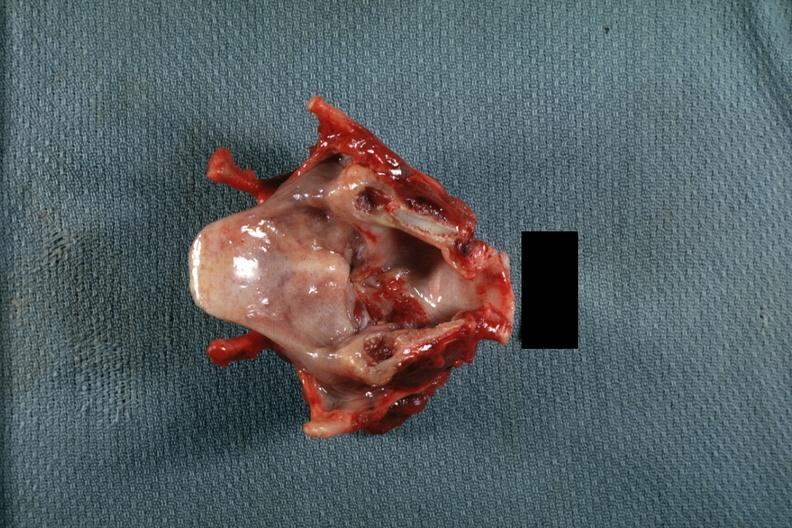what is present?
Answer the question using a single word or phrase. Larynx 